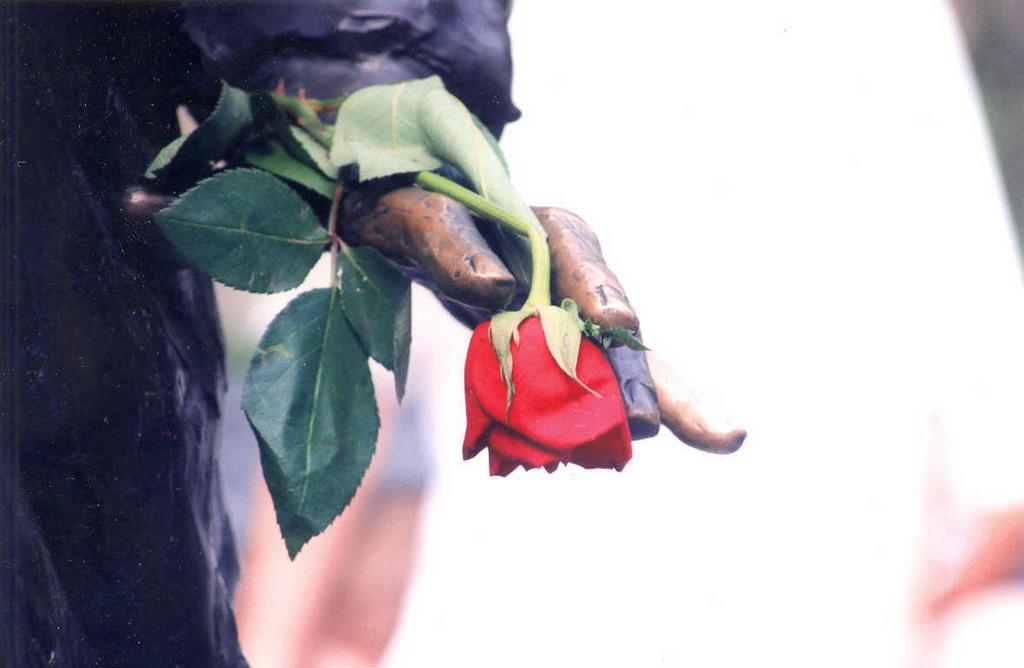What is located on the left side of the image? There is a sculpture on the left side of the image. What is the sculpture holding in its hand? The sculpture has a rose in its hand. What type of sand can be seen on the slope in the image? There is no sand or slope present in the image; it features a sculpture holding a rose. 